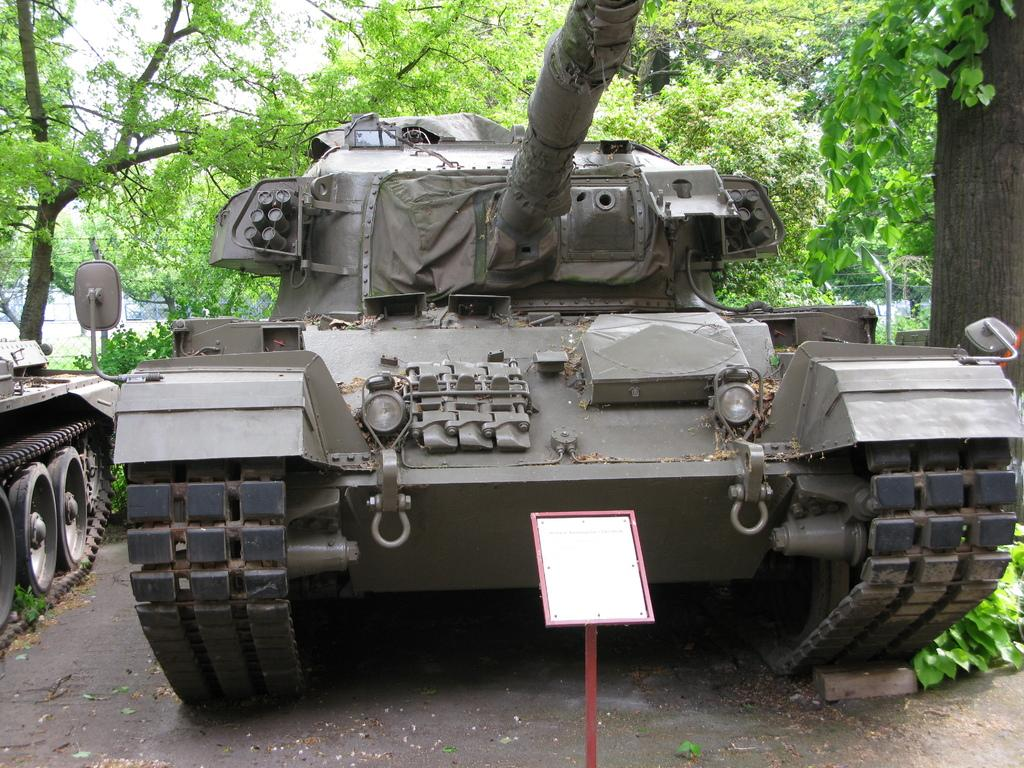What type of vehicles are present in the image? There are two combat vehicles in the image. What can be seen in the background of the image? There are a lot of trees around the vehicles. Is there any signage or noticeable object in the front of the image? Yes, there is a small board attached to a pole in the front of the image. What type of thrill can be experienced while sitting on the sofa in the image? There is no sofa present in the image, so it is not possible to experience any thrill while sitting on it. 